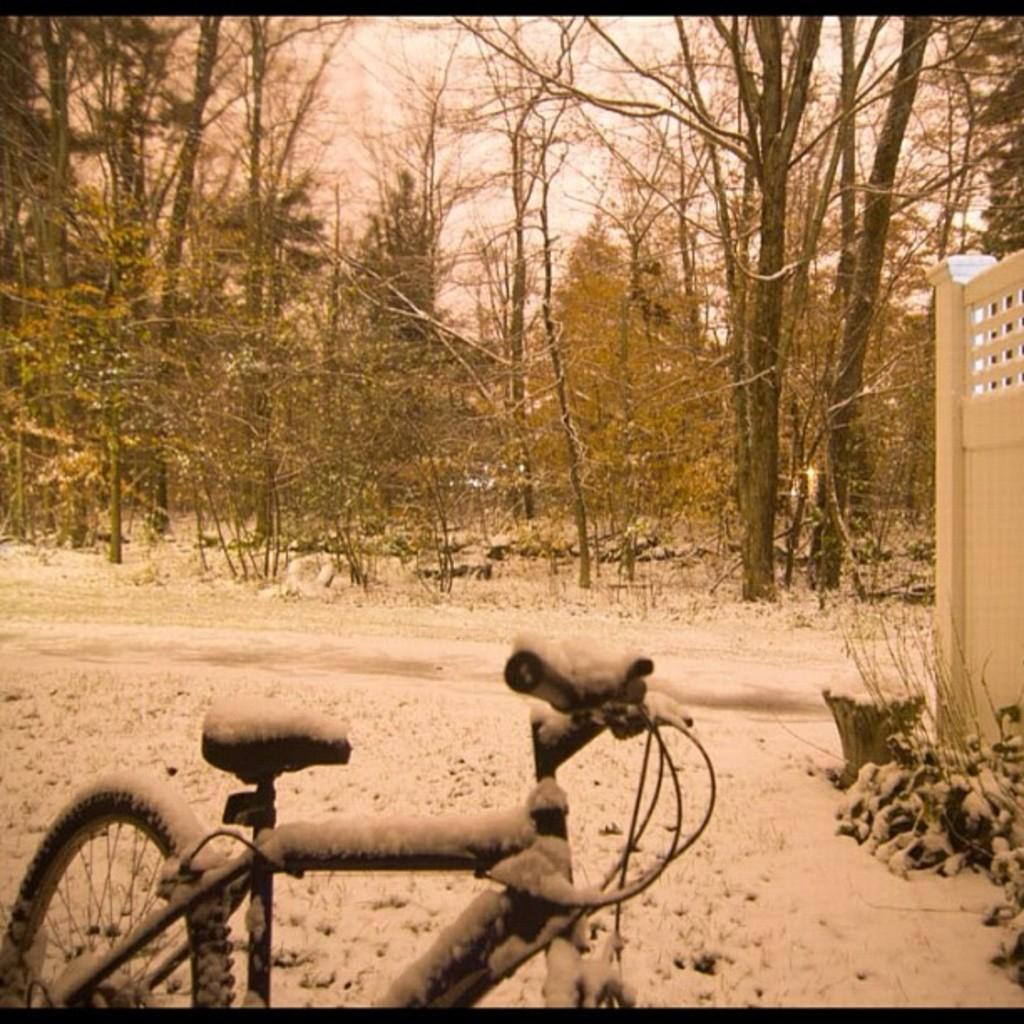What type of image is present in the picture? The image contains an old photograph. What can be seen in the old photograph? There is a bicycle, the ground, plants, a wall, trees, and the sky visible in the old photograph. What is the background of the old photograph? The sky is visible in the background of the old photograph. What book is the mother reading to the child in the image? There is no mother or child present in the image, nor is there any book or reading activity taking place. 